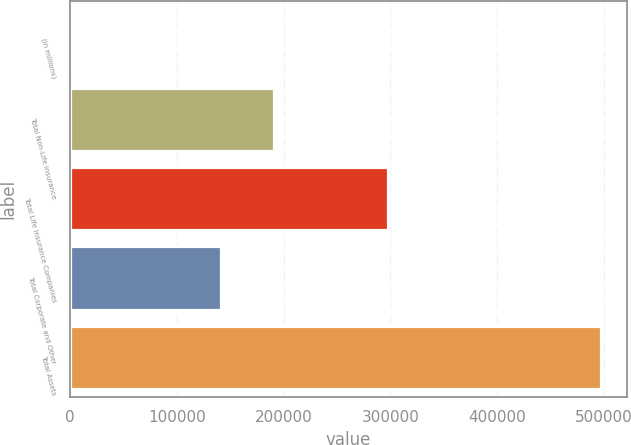<chart> <loc_0><loc_0><loc_500><loc_500><bar_chart><fcel>(in millions)<fcel>Total Non-Life Insurance<fcel>Total Life Insurance Companies<fcel>Total Corporate and Other<fcel>Total Assets<nl><fcel>2015<fcel>191141<fcel>297499<fcel>141648<fcel>496943<nl></chart> 